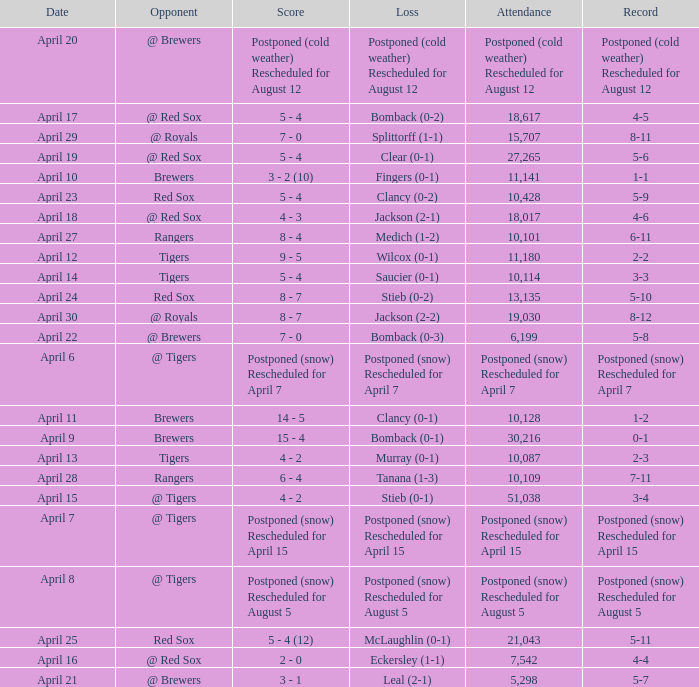What is the score for the game that has an attendance of 5,298? 3 - 1. 